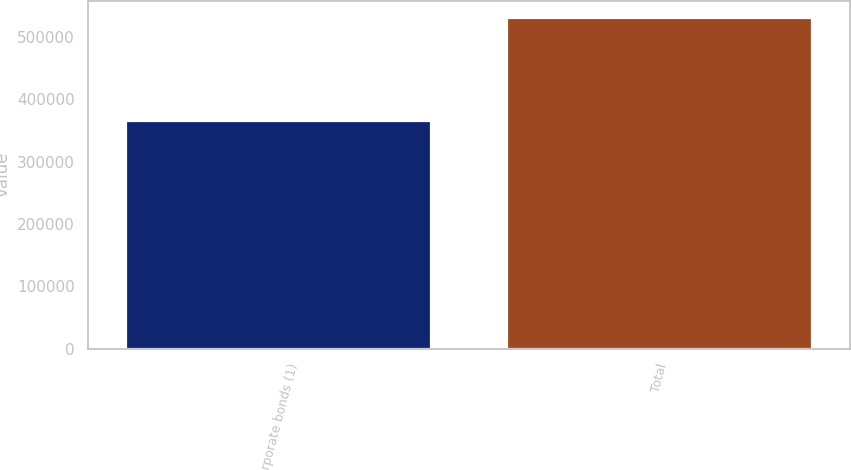Convert chart. <chart><loc_0><loc_0><loc_500><loc_500><bar_chart><fcel>Corporate bonds (1)<fcel>Total<nl><fcel>364931<fcel>531594<nl></chart> 